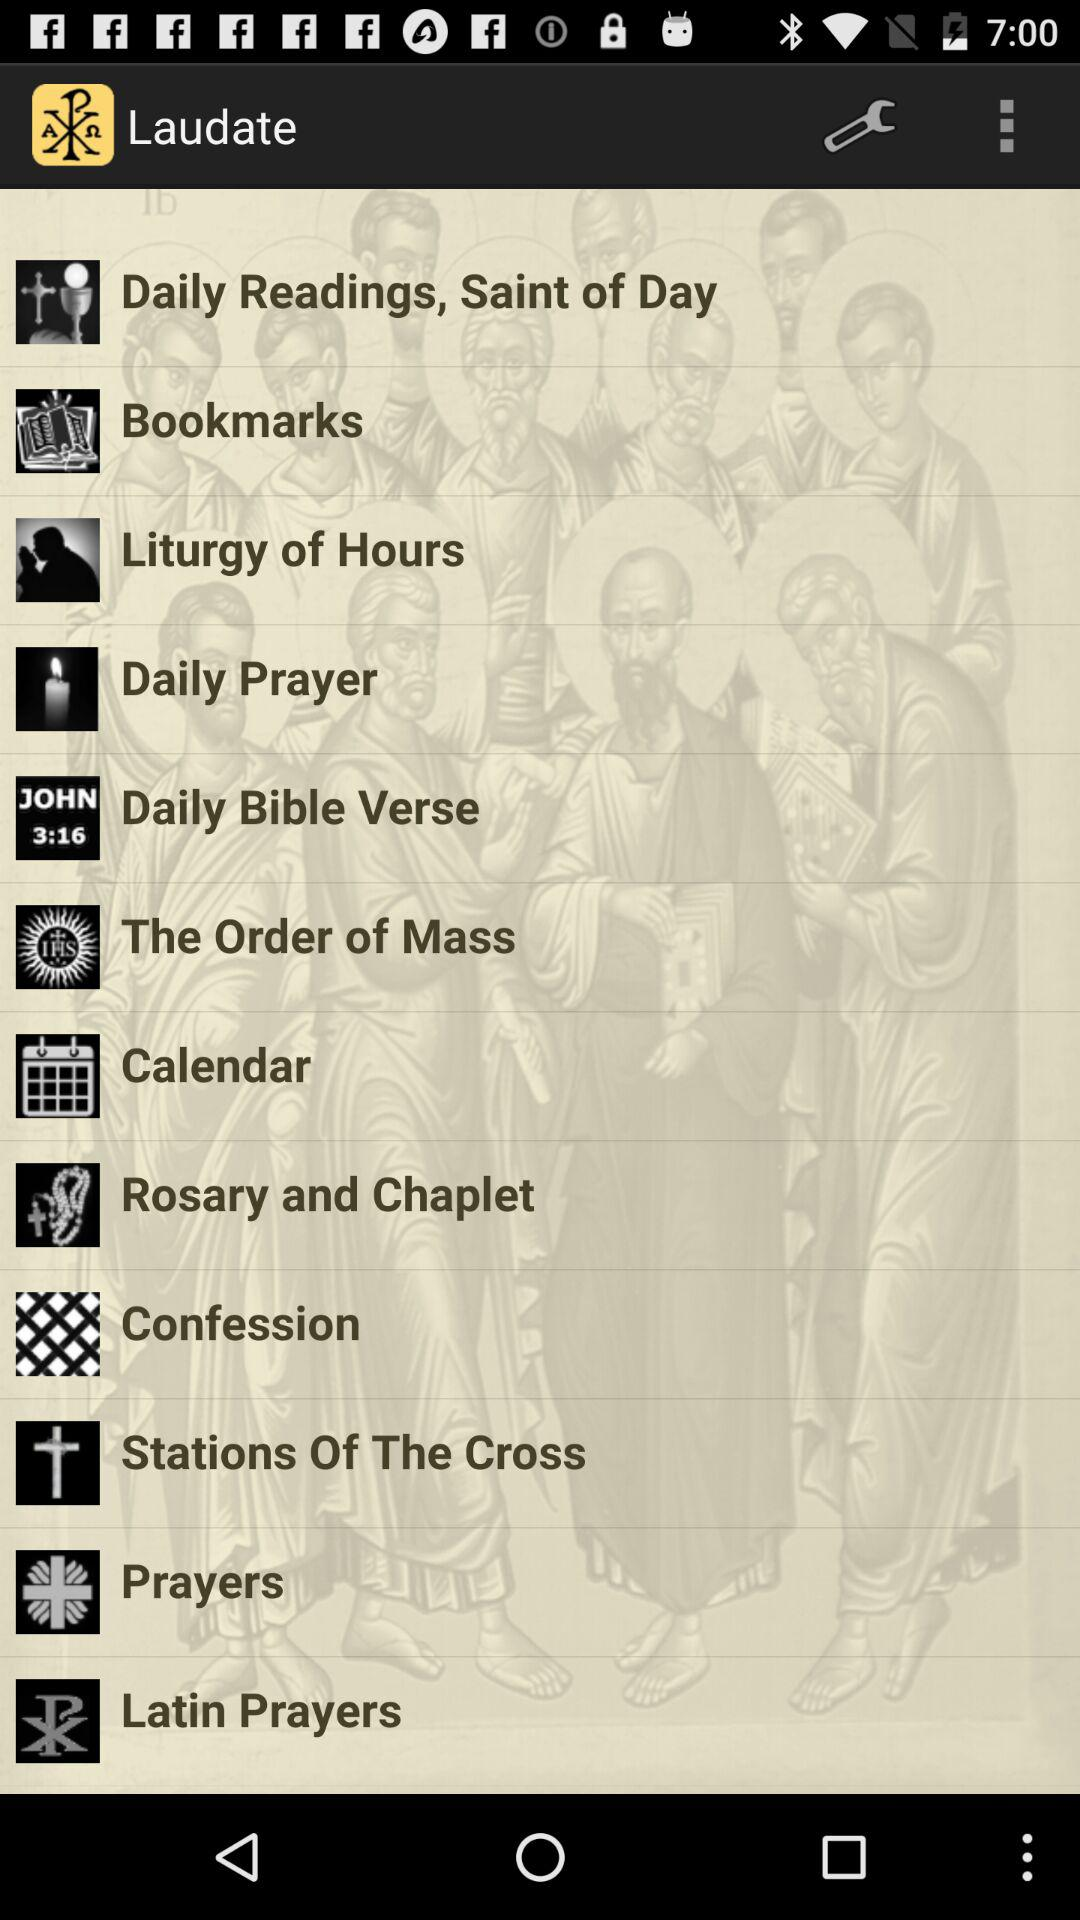What is the application name? The application name is "Laudate". 